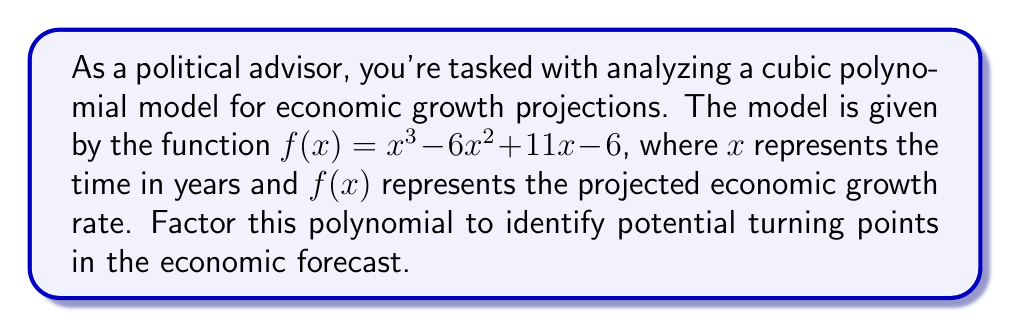Teach me how to tackle this problem. Let's factor this cubic polynomial step by step:

1) First, we'll check if there's a rational root using the rational root theorem. The possible rational roots are the factors of the constant term: $\pm 1, \pm 2, \pm 3, \pm 6$.

2) Testing these values, we find that $f(1) = 0$. So $(x-1)$ is a factor.

3) We can use polynomial long division to divide $f(x)$ by $(x-1)$:

   $$\frac{x^3 - 6x^2 + 11x - 6}{x-1} = x^2 - 5x + 6$$

4) So we have: $f(x) = (x-1)(x^2 - 5x + 6)$

5) Now we need to factor the quadratic term $x^2 - 5x + 6$. We can do this by finding two numbers that multiply to give 6 and add to give -5. These numbers are -2 and -3.

6) Therefore, $x^2 - 5x + 6 = (x-2)(x-3)$

7) Combining all factors, we get:

   $$f(x) = (x-1)(x-2)(x-3)$$

This factorization reveals that the economic growth rate will be zero when $x = 1$, $x = 2$, and $x = 3$, corresponding to potential turning points in years 1, 2, and 3 of the forecast.
Answer: $(x-1)(x-2)(x-3)$ 